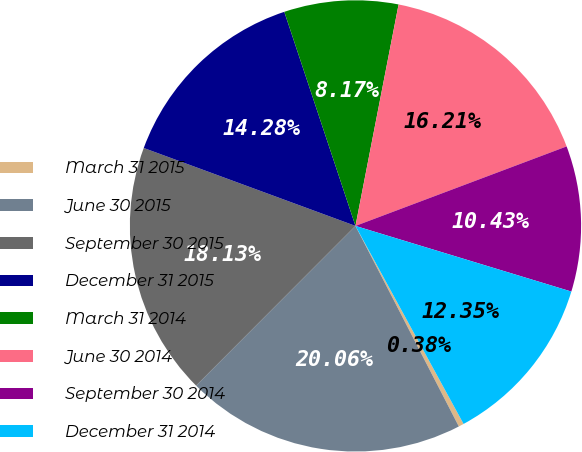<chart> <loc_0><loc_0><loc_500><loc_500><pie_chart><fcel>March 31 2015<fcel>June 30 2015<fcel>September 30 2015<fcel>December 31 2015<fcel>March 31 2014<fcel>June 30 2014<fcel>September 30 2014<fcel>December 31 2014<nl><fcel>0.38%<fcel>20.06%<fcel>18.13%<fcel>14.28%<fcel>8.17%<fcel>16.21%<fcel>10.43%<fcel>12.35%<nl></chart> 